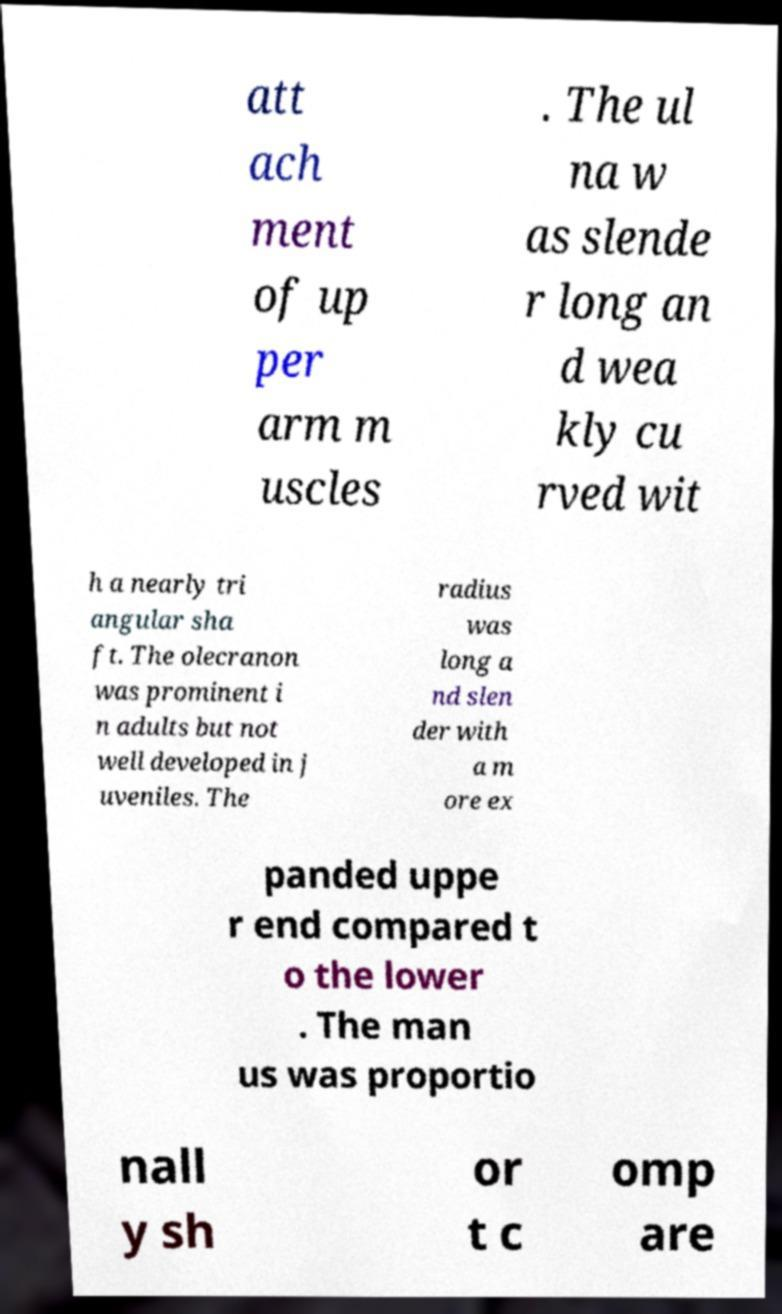There's text embedded in this image that I need extracted. Can you transcribe it verbatim? att ach ment of up per arm m uscles . The ul na w as slende r long an d wea kly cu rved wit h a nearly tri angular sha ft. The olecranon was prominent i n adults but not well developed in j uveniles. The radius was long a nd slen der with a m ore ex panded uppe r end compared t o the lower . The man us was proportio nall y sh or t c omp are 